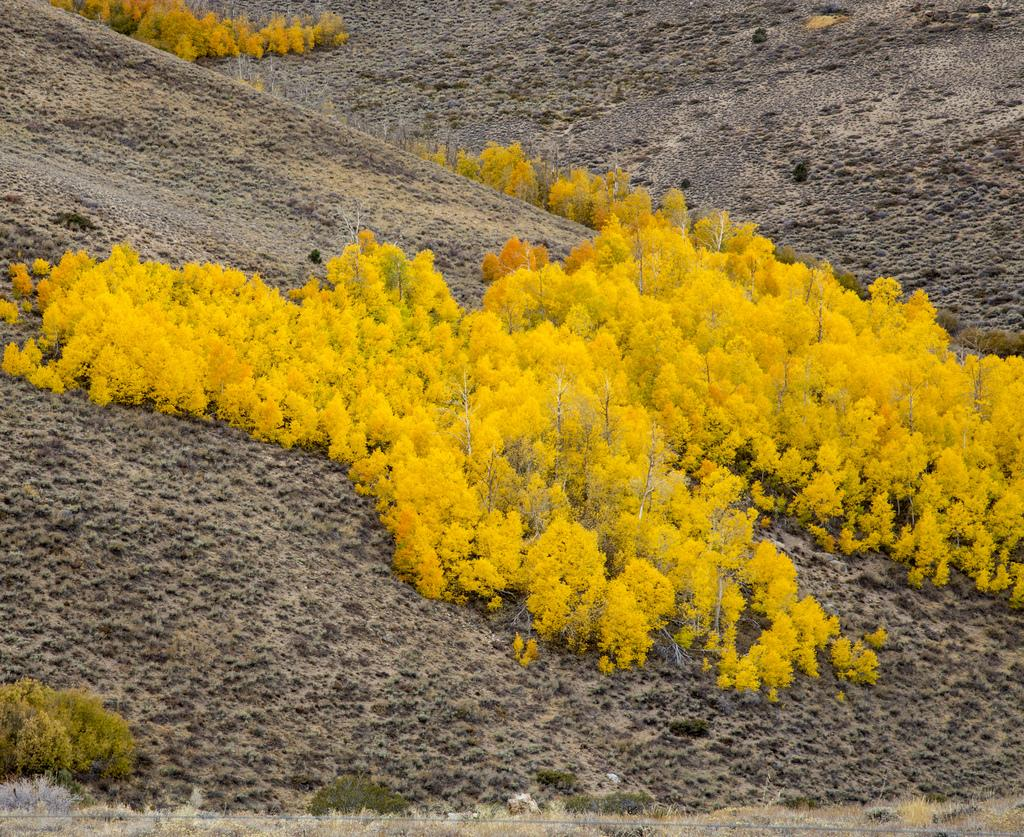What celestial bodies are present in the image? There are planets in the image. What type of surface is visible at the bottom of the image? There is soil at the bottom of the image. How many waves can be seen crashing on the shore in the image? There are no waves present in the image, as it features planets and soil. What type of bird is visible in the image? There are no birds, including ducks, present in the image. 